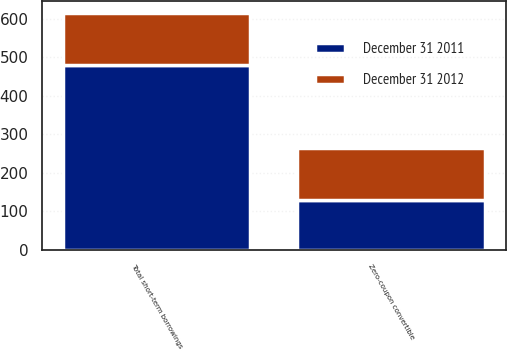<chart> <loc_0><loc_0><loc_500><loc_500><stacked_bar_chart><ecel><fcel>Zero-coupon convertible<fcel>Total short-term borrowings<nl><fcel>December 31 2011<fcel>130<fcel>480<nl><fcel>December 31 2012<fcel>135.5<fcel>135.5<nl></chart> 